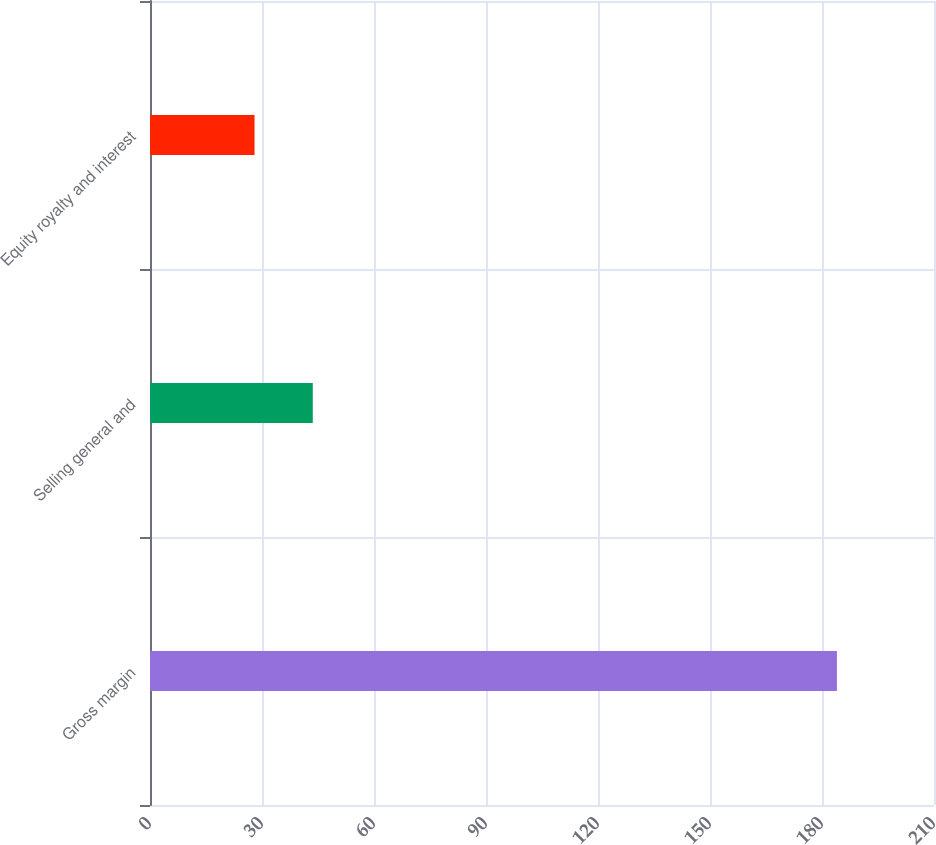<chart> <loc_0><loc_0><loc_500><loc_500><bar_chart><fcel>Gross margin<fcel>Selling general and<fcel>Equity royalty and interest<nl><fcel>184<fcel>43.6<fcel>28<nl></chart> 